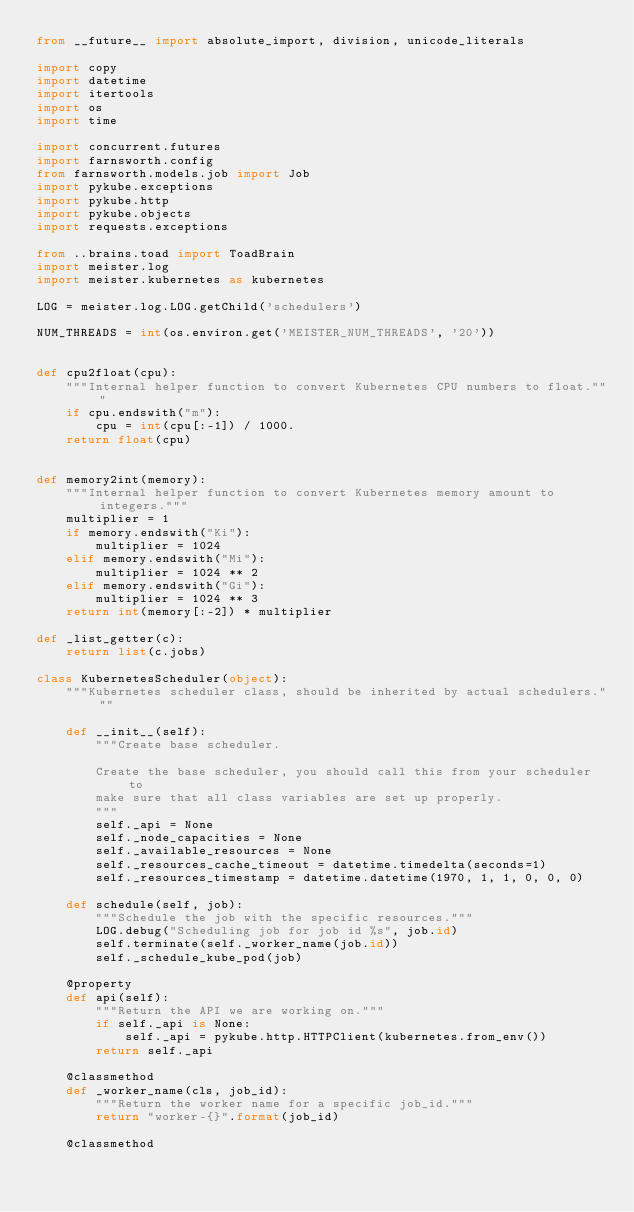<code> <loc_0><loc_0><loc_500><loc_500><_Python_>from __future__ import absolute_import, division, unicode_literals

import copy
import datetime
import itertools
import os
import time

import concurrent.futures
import farnsworth.config
from farnsworth.models.job import Job
import pykube.exceptions
import pykube.http
import pykube.objects
import requests.exceptions

from ..brains.toad import ToadBrain
import meister.log
import meister.kubernetes as kubernetes

LOG = meister.log.LOG.getChild('schedulers')

NUM_THREADS = int(os.environ.get('MEISTER_NUM_THREADS', '20'))


def cpu2float(cpu):
    """Internal helper function to convert Kubernetes CPU numbers to float."""
    if cpu.endswith("m"):
        cpu = int(cpu[:-1]) / 1000.
    return float(cpu)


def memory2int(memory):
    """Internal helper function to convert Kubernetes memory amount to integers."""
    multiplier = 1
    if memory.endswith("Ki"):
        multiplier = 1024
    elif memory.endswith("Mi"):
        multiplier = 1024 ** 2
    elif memory.endswith("Gi"):
        multiplier = 1024 ** 3
    return int(memory[:-2]) * multiplier

def _list_getter(c):
    return list(c.jobs)

class KubernetesScheduler(object):
    """Kubernetes scheduler class, should be inherited by actual schedulers."""

    def __init__(self):
        """Create base scheduler.

        Create the base scheduler, you should call this from your scheduler to
        make sure that all class variables are set up properly.
        """
        self._api = None
        self._node_capacities = None
        self._available_resources = None
        self._resources_cache_timeout = datetime.timedelta(seconds=1)
        self._resources_timestamp = datetime.datetime(1970, 1, 1, 0, 0, 0)

    def schedule(self, job):
        """Schedule the job with the specific resources."""
        LOG.debug("Scheduling job for job id %s", job.id)
        self.terminate(self._worker_name(job.id))
        self._schedule_kube_pod(job)

    @property
    def api(self):
        """Return the API we are working on."""
        if self._api is None:
            self._api = pykube.http.HTTPClient(kubernetes.from_env())
        return self._api

    @classmethod
    def _worker_name(cls, job_id):
        """Return the worker name for a specific job_id."""
        return "worker-{}".format(job_id)

    @classmethod</code> 